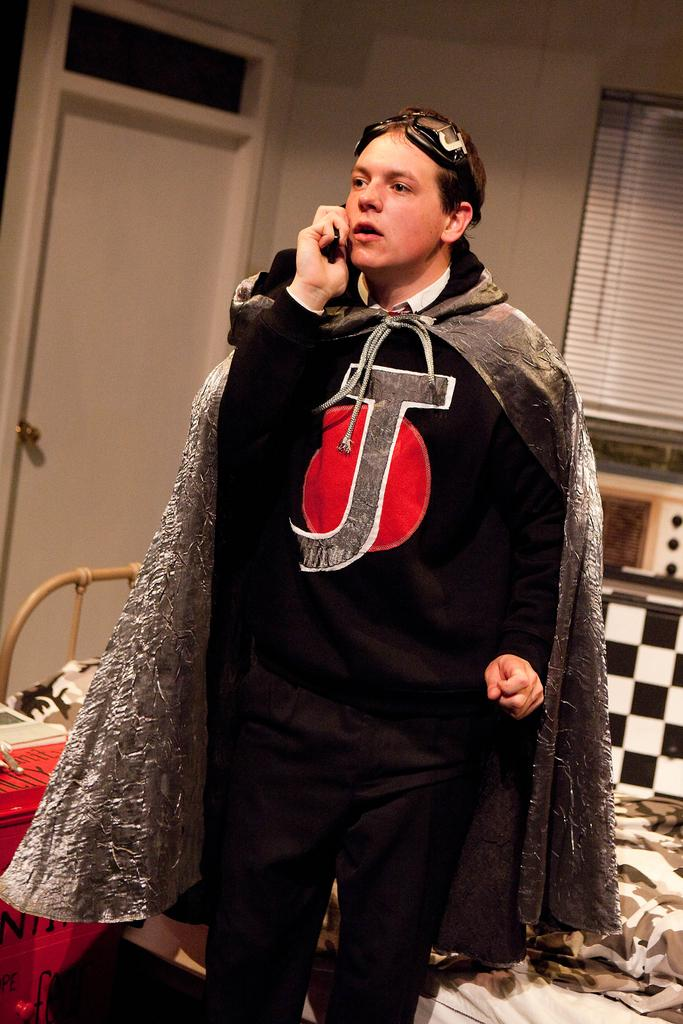What is the man in the image doing? The man is standing in the center of the image and speaking on a phone. What can be seen in the background of the image? There is a door, a window, and a wall in the background of the image. What type of butter is being used to wash the fowl in the image? There is no butter, washing, or fowl present in the image. 